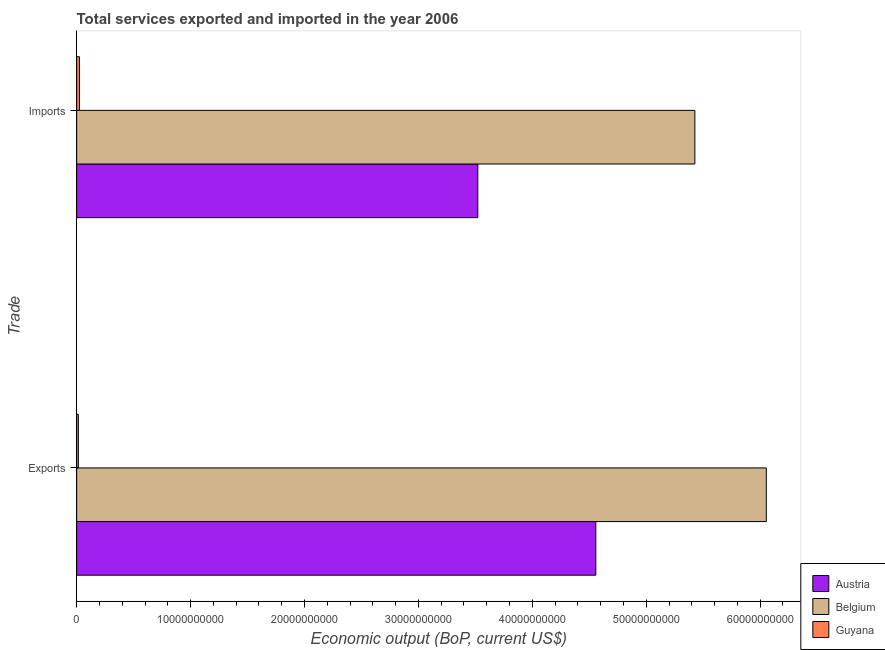How many groups of bars are there?
Ensure brevity in your answer.  2. Are the number of bars per tick equal to the number of legend labels?
Provide a succinct answer. Yes. Are the number of bars on each tick of the Y-axis equal?
Your answer should be very brief. Yes. How many bars are there on the 1st tick from the top?
Provide a succinct answer. 3. What is the label of the 2nd group of bars from the top?
Provide a succinct answer. Exports. What is the amount of service exports in Guyana?
Keep it short and to the point. 1.48e+08. Across all countries, what is the maximum amount of service exports?
Provide a succinct answer. 6.05e+1. Across all countries, what is the minimum amount of service imports?
Ensure brevity in your answer.  2.45e+08. In which country was the amount of service imports maximum?
Keep it short and to the point. Belgium. In which country was the amount of service imports minimum?
Your answer should be very brief. Guyana. What is the total amount of service imports in the graph?
Ensure brevity in your answer.  8.97e+1. What is the difference between the amount of service imports in Belgium and that in Austria?
Provide a short and direct response. 1.91e+1. What is the difference between the amount of service exports in Belgium and the amount of service imports in Austria?
Your answer should be compact. 2.53e+1. What is the average amount of service exports per country?
Offer a terse response. 3.54e+1. What is the difference between the amount of service imports and amount of service exports in Austria?
Your answer should be very brief. -1.04e+1. In how many countries, is the amount of service imports greater than 50000000000 US$?
Your response must be concise. 1. What is the ratio of the amount of service imports in Belgium to that in Guyana?
Offer a terse response. 221.13. Is the amount of service imports in Guyana less than that in Austria?
Provide a short and direct response. Yes. In how many countries, is the amount of service exports greater than the average amount of service exports taken over all countries?
Keep it short and to the point. 2. What does the 1st bar from the top in Exports represents?
Provide a succinct answer. Guyana. What does the 3rd bar from the bottom in Imports represents?
Keep it short and to the point. Guyana. How many bars are there?
Your answer should be very brief. 6. Are all the bars in the graph horizontal?
Your answer should be compact. Yes. How many countries are there in the graph?
Ensure brevity in your answer.  3. Does the graph contain grids?
Provide a succinct answer. No. Where does the legend appear in the graph?
Your answer should be compact. Bottom right. How many legend labels are there?
Offer a terse response. 3. How are the legend labels stacked?
Make the answer very short. Vertical. What is the title of the graph?
Keep it short and to the point. Total services exported and imported in the year 2006. What is the label or title of the X-axis?
Your answer should be very brief. Economic output (BoP, current US$). What is the label or title of the Y-axis?
Your answer should be compact. Trade. What is the Economic output (BoP, current US$) of Austria in Exports?
Keep it short and to the point. 4.56e+1. What is the Economic output (BoP, current US$) in Belgium in Exports?
Keep it short and to the point. 6.05e+1. What is the Economic output (BoP, current US$) of Guyana in Exports?
Give a very brief answer. 1.48e+08. What is the Economic output (BoP, current US$) of Austria in Imports?
Offer a very short reply. 3.52e+1. What is the Economic output (BoP, current US$) in Belgium in Imports?
Keep it short and to the point. 5.43e+1. What is the Economic output (BoP, current US$) of Guyana in Imports?
Give a very brief answer. 2.45e+08. Across all Trade, what is the maximum Economic output (BoP, current US$) in Austria?
Your response must be concise. 4.56e+1. Across all Trade, what is the maximum Economic output (BoP, current US$) of Belgium?
Your response must be concise. 6.05e+1. Across all Trade, what is the maximum Economic output (BoP, current US$) in Guyana?
Make the answer very short. 2.45e+08. Across all Trade, what is the minimum Economic output (BoP, current US$) in Austria?
Offer a terse response. 3.52e+1. Across all Trade, what is the minimum Economic output (BoP, current US$) in Belgium?
Provide a succinct answer. 5.43e+1. Across all Trade, what is the minimum Economic output (BoP, current US$) of Guyana?
Make the answer very short. 1.48e+08. What is the total Economic output (BoP, current US$) of Austria in the graph?
Provide a succinct answer. 8.08e+1. What is the total Economic output (BoP, current US$) in Belgium in the graph?
Keep it short and to the point. 1.15e+11. What is the total Economic output (BoP, current US$) of Guyana in the graph?
Give a very brief answer. 3.93e+08. What is the difference between the Economic output (BoP, current US$) of Austria in Exports and that in Imports?
Ensure brevity in your answer.  1.04e+1. What is the difference between the Economic output (BoP, current US$) of Belgium in Exports and that in Imports?
Offer a very short reply. 6.27e+09. What is the difference between the Economic output (BoP, current US$) in Guyana in Exports and that in Imports?
Your answer should be compact. -9.78e+07. What is the difference between the Economic output (BoP, current US$) in Austria in Exports and the Economic output (BoP, current US$) in Belgium in Imports?
Offer a very short reply. -8.69e+09. What is the difference between the Economic output (BoP, current US$) of Austria in Exports and the Economic output (BoP, current US$) of Guyana in Imports?
Provide a succinct answer. 4.53e+1. What is the difference between the Economic output (BoP, current US$) of Belgium in Exports and the Economic output (BoP, current US$) of Guyana in Imports?
Your response must be concise. 6.03e+1. What is the average Economic output (BoP, current US$) in Austria per Trade?
Your answer should be compact. 4.04e+1. What is the average Economic output (BoP, current US$) in Belgium per Trade?
Make the answer very short. 5.74e+1. What is the average Economic output (BoP, current US$) of Guyana per Trade?
Provide a short and direct response. 1.97e+08. What is the difference between the Economic output (BoP, current US$) in Austria and Economic output (BoP, current US$) in Belgium in Exports?
Keep it short and to the point. -1.50e+1. What is the difference between the Economic output (BoP, current US$) of Austria and Economic output (BoP, current US$) of Guyana in Exports?
Offer a terse response. 4.54e+1. What is the difference between the Economic output (BoP, current US$) in Belgium and Economic output (BoP, current US$) in Guyana in Exports?
Ensure brevity in your answer.  6.04e+1. What is the difference between the Economic output (BoP, current US$) in Austria and Economic output (BoP, current US$) in Belgium in Imports?
Provide a succinct answer. -1.91e+1. What is the difference between the Economic output (BoP, current US$) of Austria and Economic output (BoP, current US$) of Guyana in Imports?
Provide a succinct answer. 3.50e+1. What is the difference between the Economic output (BoP, current US$) of Belgium and Economic output (BoP, current US$) of Guyana in Imports?
Your answer should be very brief. 5.40e+1. What is the ratio of the Economic output (BoP, current US$) in Austria in Exports to that in Imports?
Provide a short and direct response. 1.29. What is the ratio of the Economic output (BoP, current US$) in Belgium in Exports to that in Imports?
Make the answer very short. 1.12. What is the ratio of the Economic output (BoP, current US$) in Guyana in Exports to that in Imports?
Your answer should be very brief. 0.6. What is the difference between the highest and the second highest Economic output (BoP, current US$) of Austria?
Provide a succinct answer. 1.04e+1. What is the difference between the highest and the second highest Economic output (BoP, current US$) in Belgium?
Ensure brevity in your answer.  6.27e+09. What is the difference between the highest and the second highest Economic output (BoP, current US$) of Guyana?
Ensure brevity in your answer.  9.78e+07. What is the difference between the highest and the lowest Economic output (BoP, current US$) of Austria?
Your answer should be very brief. 1.04e+1. What is the difference between the highest and the lowest Economic output (BoP, current US$) in Belgium?
Make the answer very short. 6.27e+09. What is the difference between the highest and the lowest Economic output (BoP, current US$) of Guyana?
Offer a very short reply. 9.78e+07. 